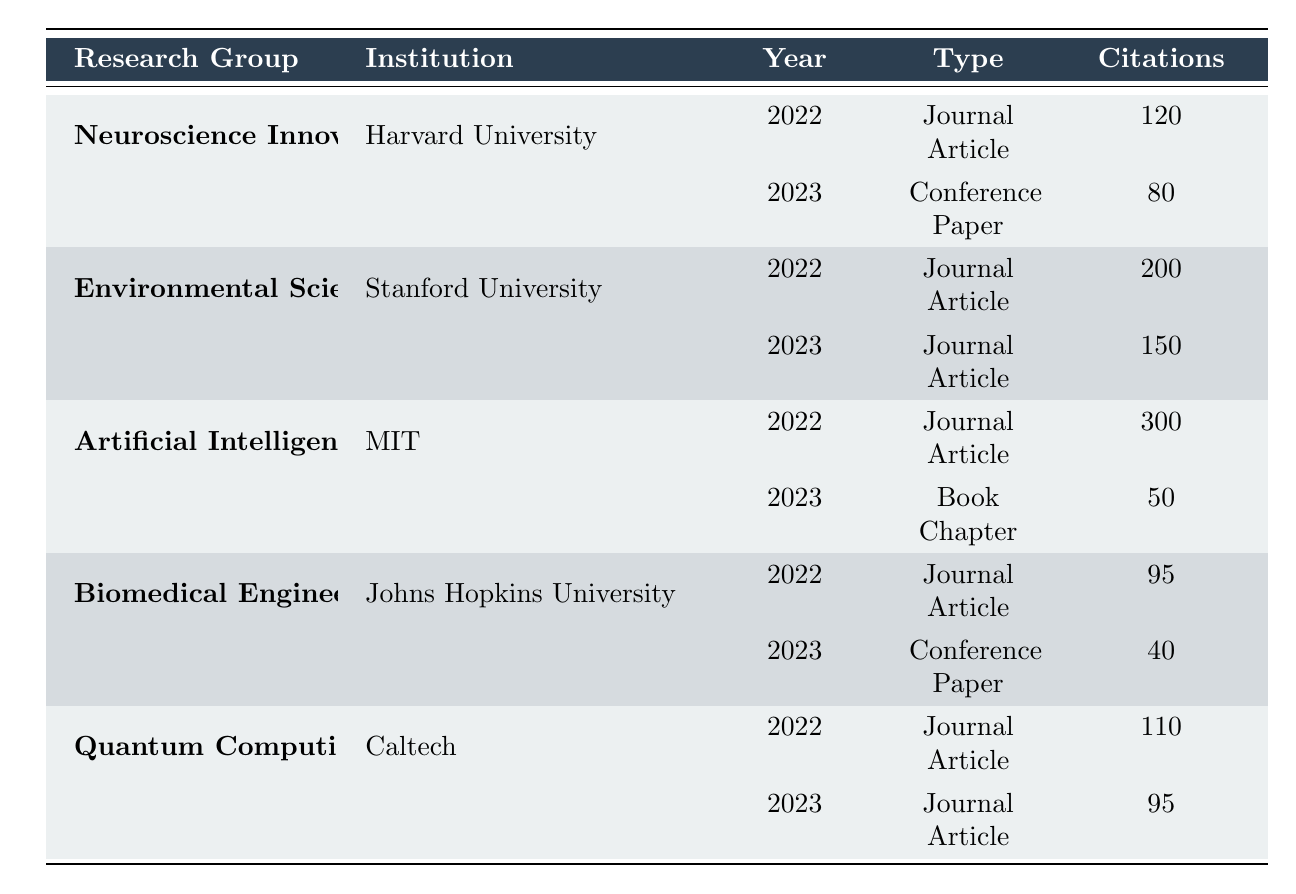What was the total number of publications by the Environmental Science Group in 2022? The Environmental Science Group has one publication listed for 2022, titled "Climate Change Impact on Biodiversity". Therefore, the total number of publications for that group in 2022 is 1.
Answer: 1 Which research group had the highest number of citations in 2022? In 2022, the publications for each group had the following citations: Neuroscience Innovations Lab (120), Environmental Science Group (200), Artificial Intelligence Research Team (300), Biomedical Engineering Department (95), and Quantum Computing Research Unit (110). The highest citations are from the Artificial Intelligence Research Team with 300 citations.
Answer: Artificial Intelligence Research Team Does the Biomedical Engineering Department have more publications than the Quantum Computing Research Unit in 2023? The Biomedical Engineering Department has 1 publication in 2023 titled "Wearable Tech: Monitoring Health on the Go", and the Quantum Computing Research Unit also has 1 publication in 2023 titled "The Future of Quantum Communications". Since both groups have an equal number of publications, the answer is no.
Answer: No What is the average number of citations per publication for the Artificial Intelligence Research Team over the two years? The Artificial Intelligence Research Team has 2 publications: one with 300 citations in 2022 and one with 50 citations in 2023. To find the average, sum the citations (300 + 50 = 350) and divide by the number of publications (2). The average is 350 / 2 = 175.
Answer: 175 Which institution had the least number of citations for their 2023 publication? The citations for each group in 2023 are: Neuroscience Innovations Lab (80), Environmental Science Group (150), Artificial Intelligence Research Team (50), Biomedical Engineering Department (40), and Quantum Computing Research Unit (95). The Biomedical Engineering Department has the least citations with 40.
Answer: Johns Hopkins University 